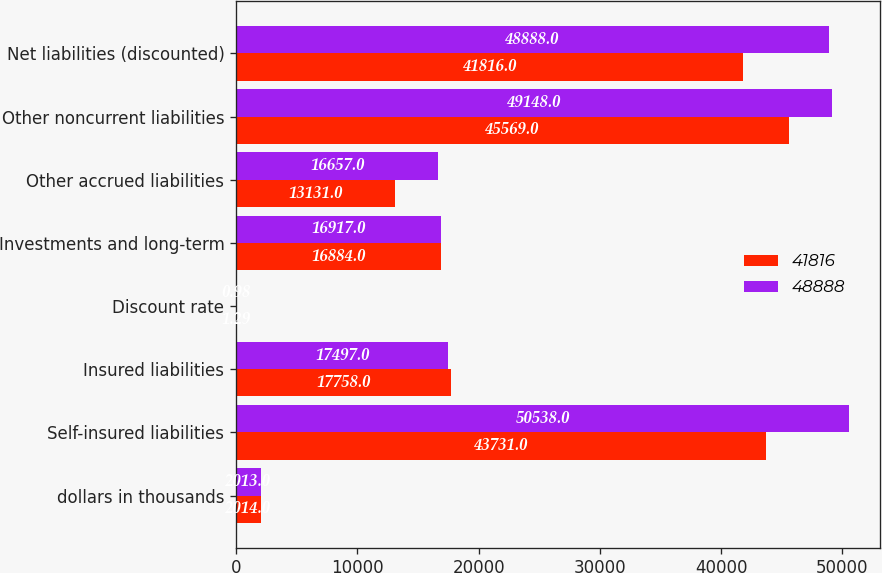Convert chart to OTSL. <chart><loc_0><loc_0><loc_500><loc_500><stacked_bar_chart><ecel><fcel>dollars in thousands<fcel>Self-insured liabilities<fcel>Insured liabilities<fcel>Discount rate<fcel>Investments and long-term<fcel>Other accrued liabilities<fcel>Other noncurrent liabilities<fcel>Net liabilities (discounted)<nl><fcel>41816<fcel>2014<fcel>43731<fcel>17758<fcel>1.29<fcel>16884<fcel>13131<fcel>45569<fcel>41816<nl><fcel>48888<fcel>2013<fcel>50538<fcel>17497<fcel>0.98<fcel>16917<fcel>16657<fcel>49148<fcel>48888<nl></chart> 